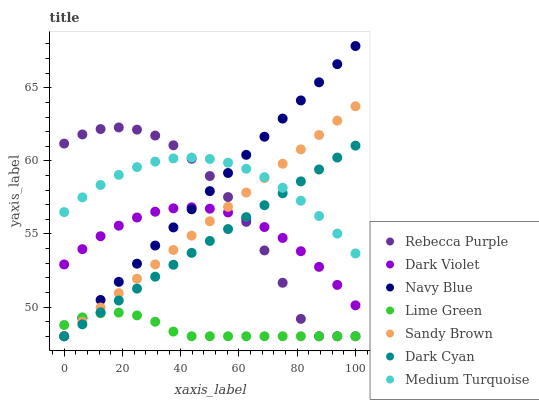Does Lime Green have the minimum area under the curve?
Answer yes or no. Yes. Does Medium Turquoise have the maximum area under the curve?
Answer yes or no. Yes. Does Dark Violet have the minimum area under the curve?
Answer yes or no. No. Does Dark Violet have the maximum area under the curve?
Answer yes or no. No. Is Sandy Brown the smoothest?
Answer yes or no. Yes. Is Rebecca Purple the roughest?
Answer yes or no. Yes. Is Dark Violet the smoothest?
Answer yes or no. No. Is Dark Violet the roughest?
Answer yes or no. No. Does Navy Blue have the lowest value?
Answer yes or no. Yes. Does Dark Violet have the lowest value?
Answer yes or no. No. Does Navy Blue have the highest value?
Answer yes or no. Yes. Does Dark Violet have the highest value?
Answer yes or no. No. Is Lime Green less than Dark Violet?
Answer yes or no. Yes. Is Medium Turquoise greater than Lime Green?
Answer yes or no. Yes. Does Rebecca Purple intersect Dark Cyan?
Answer yes or no. Yes. Is Rebecca Purple less than Dark Cyan?
Answer yes or no. No. Is Rebecca Purple greater than Dark Cyan?
Answer yes or no. No. Does Lime Green intersect Dark Violet?
Answer yes or no. No. 